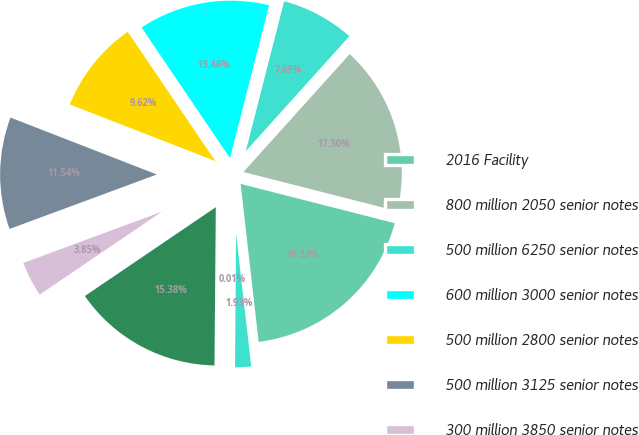<chart> <loc_0><loc_0><loc_500><loc_500><pie_chart><fcel>2016 Facility<fcel>800 million 2050 senior notes<fcel>500 million 6250 senior notes<fcel>600 million 3000 senior notes<fcel>500 million 2800 senior notes<fcel>500 million 3125 senior notes<fcel>300 million 3850 senior notes<fcel>700 million 3800 senior notes<fcel>Other<fcel>Less unamortized debt issuance<nl><fcel>19.22%<fcel>17.3%<fcel>7.69%<fcel>13.46%<fcel>9.62%<fcel>11.54%<fcel>3.85%<fcel>15.38%<fcel>0.01%<fcel>1.93%<nl></chart> 